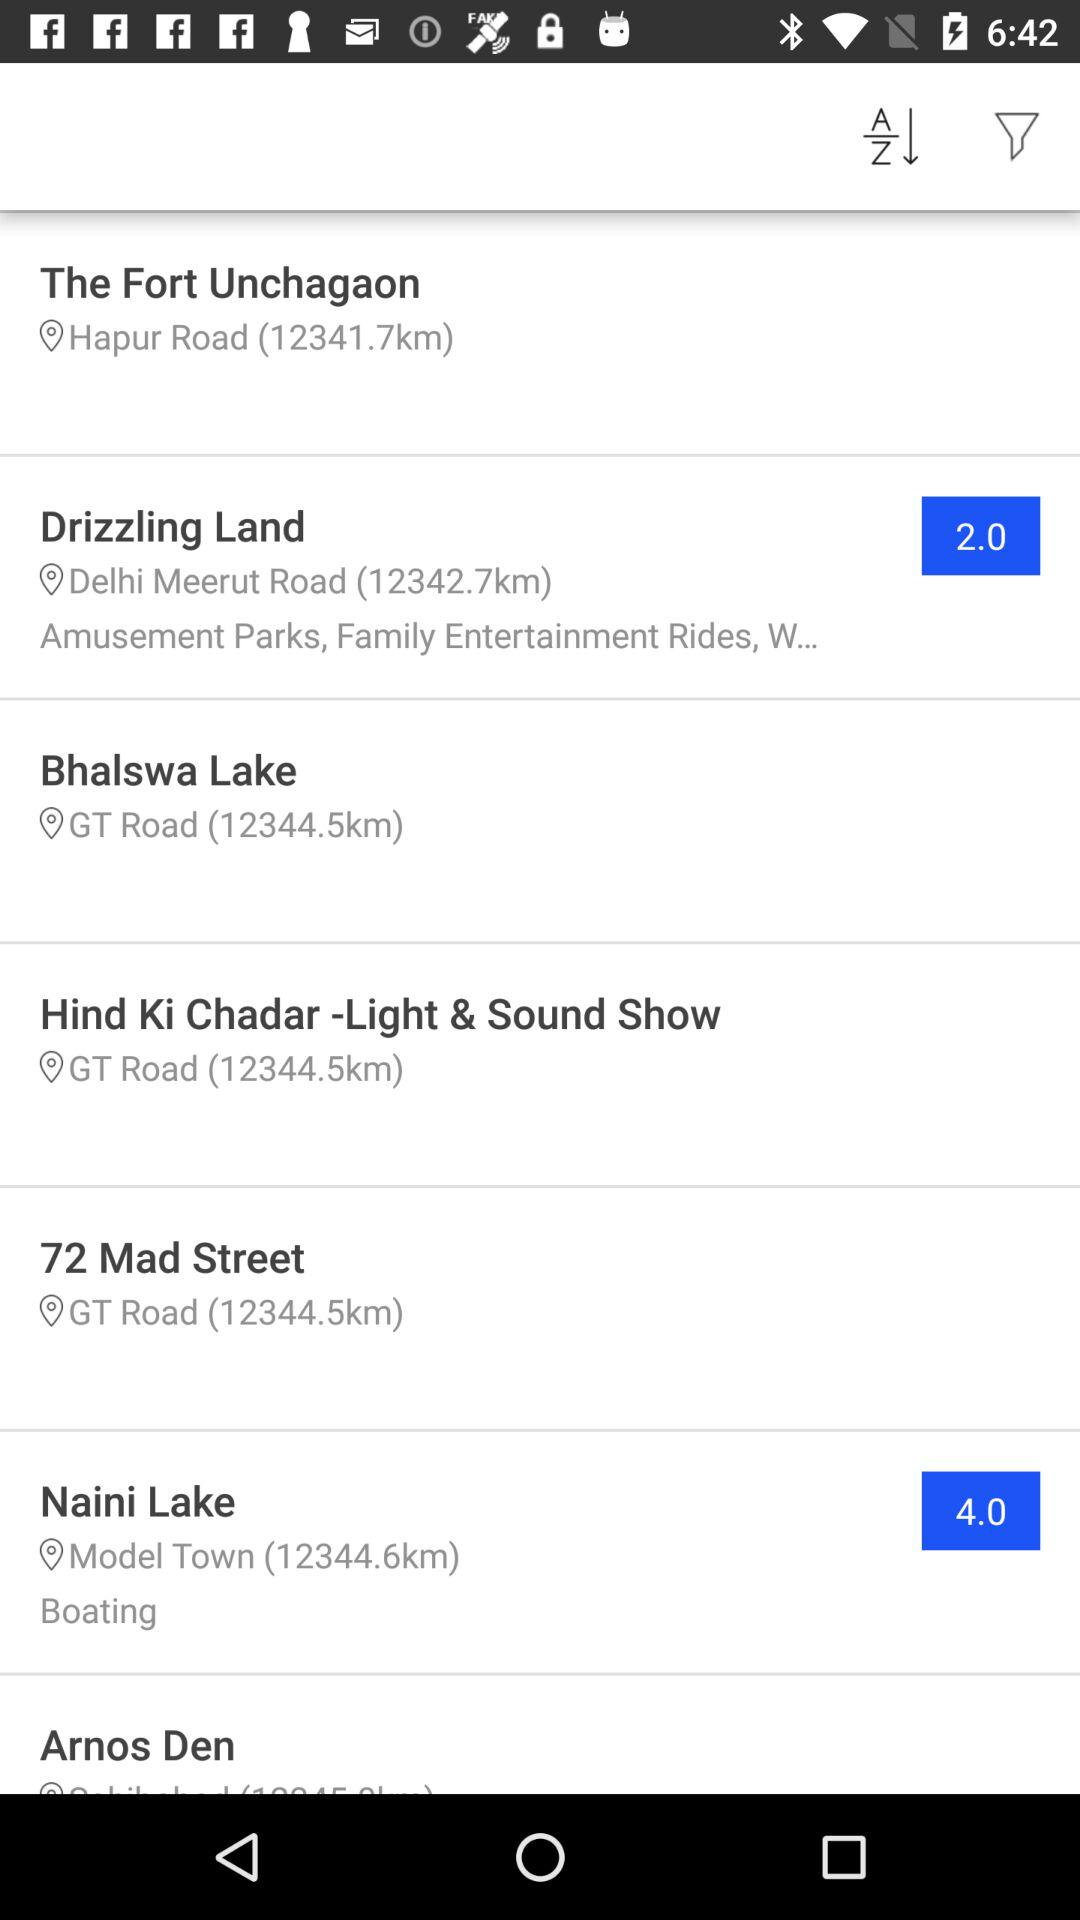What is the location of "The Fort Unchagaon"? The location is Hapur Road. 